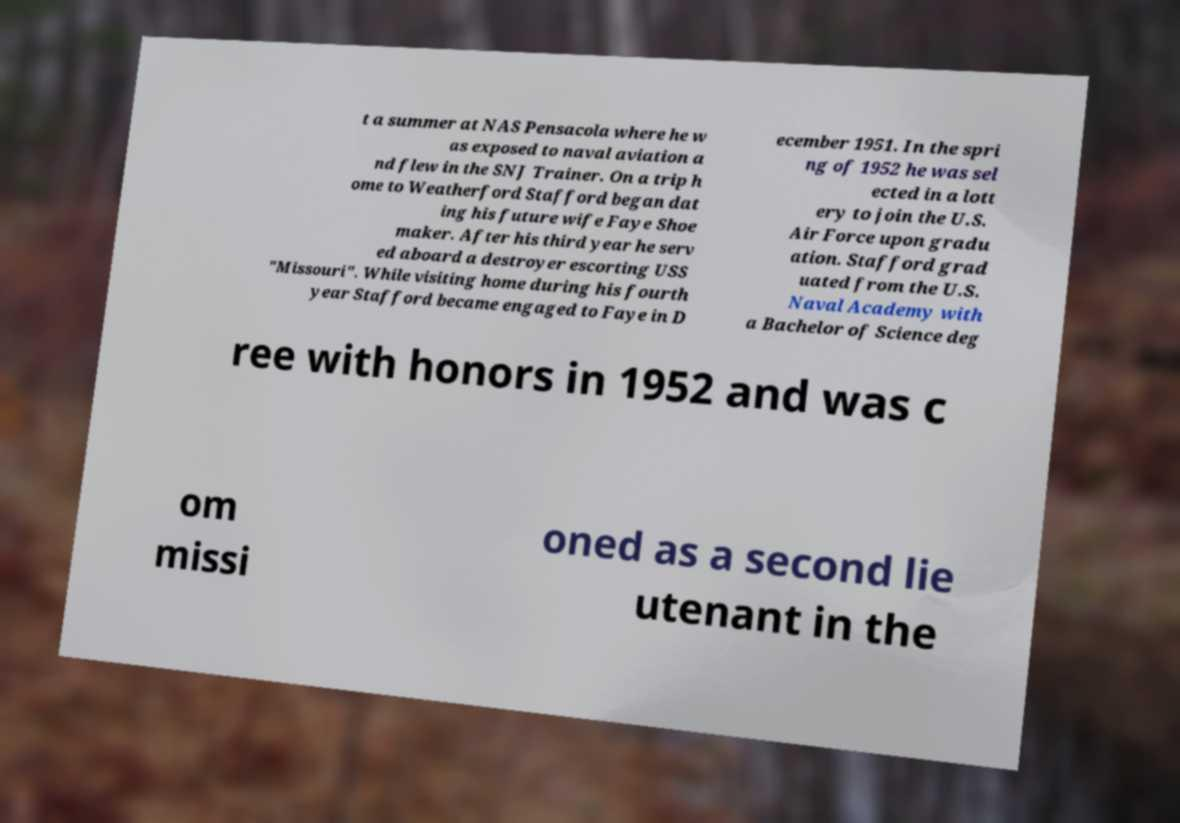What messages or text are displayed in this image? I need them in a readable, typed format. t a summer at NAS Pensacola where he w as exposed to naval aviation a nd flew in the SNJ Trainer. On a trip h ome to Weatherford Stafford began dat ing his future wife Faye Shoe maker. After his third year he serv ed aboard a destroyer escorting USS "Missouri". While visiting home during his fourth year Stafford became engaged to Faye in D ecember 1951. In the spri ng of 1952 he was sel ected in a lott ery to join the U.S. Air Force upon gradu ation. Stafford grad uated from the U.S. Naval Academy with a Bachelor of Science deg ree with honors in 1952 and was c om missi oned as a second lie utenant in the 